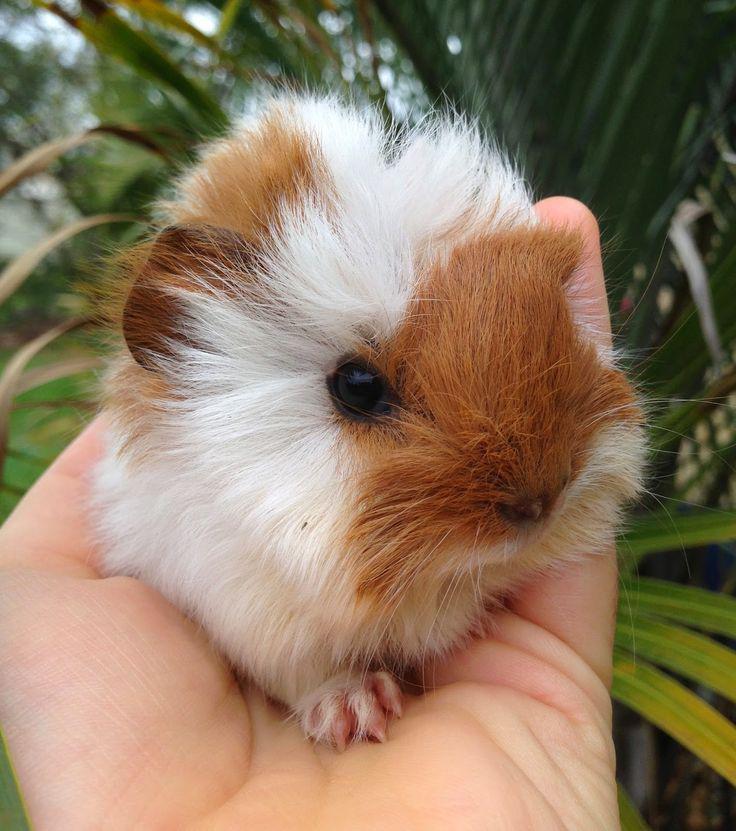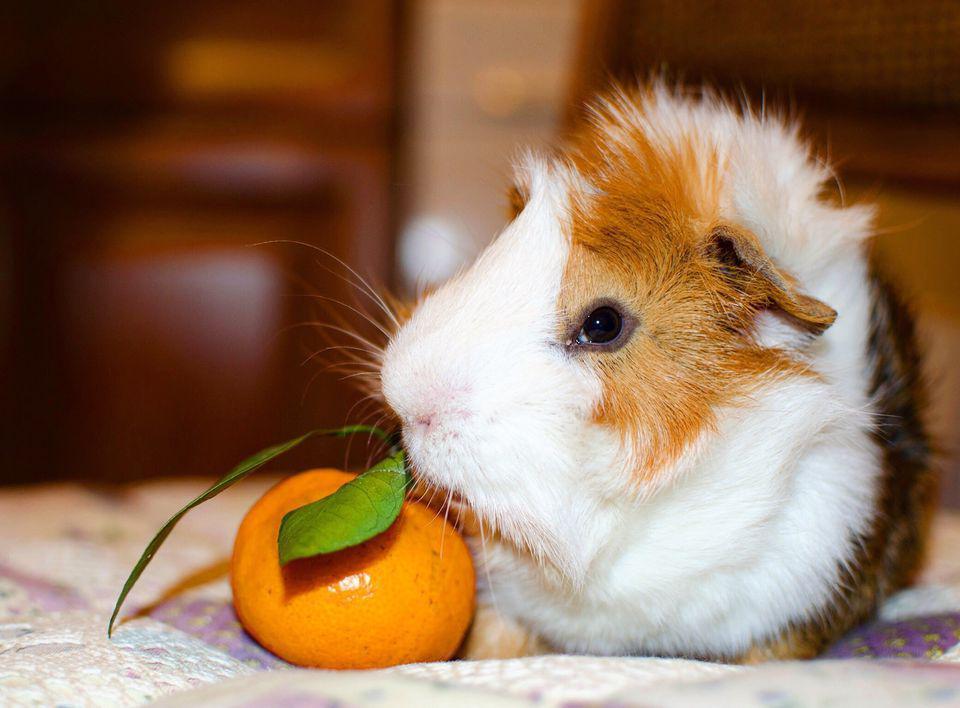The first image is the image on the left, the second image is the image on the right. Considering the images on both sides, is "There are at most two guinea pigs." valid? Answer yes or no. Yes. The first image is the image on the left, the second image is the image on the right. Given the left and right images, does the statement "There are two guinea pigs in the left image." hold true? Answer yes or no. No. 